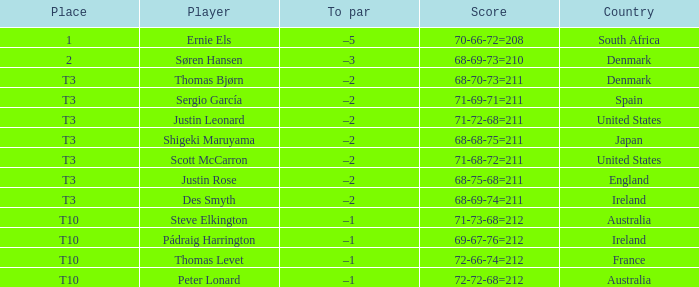What player scored 71-69-71=211? Sergio García. 